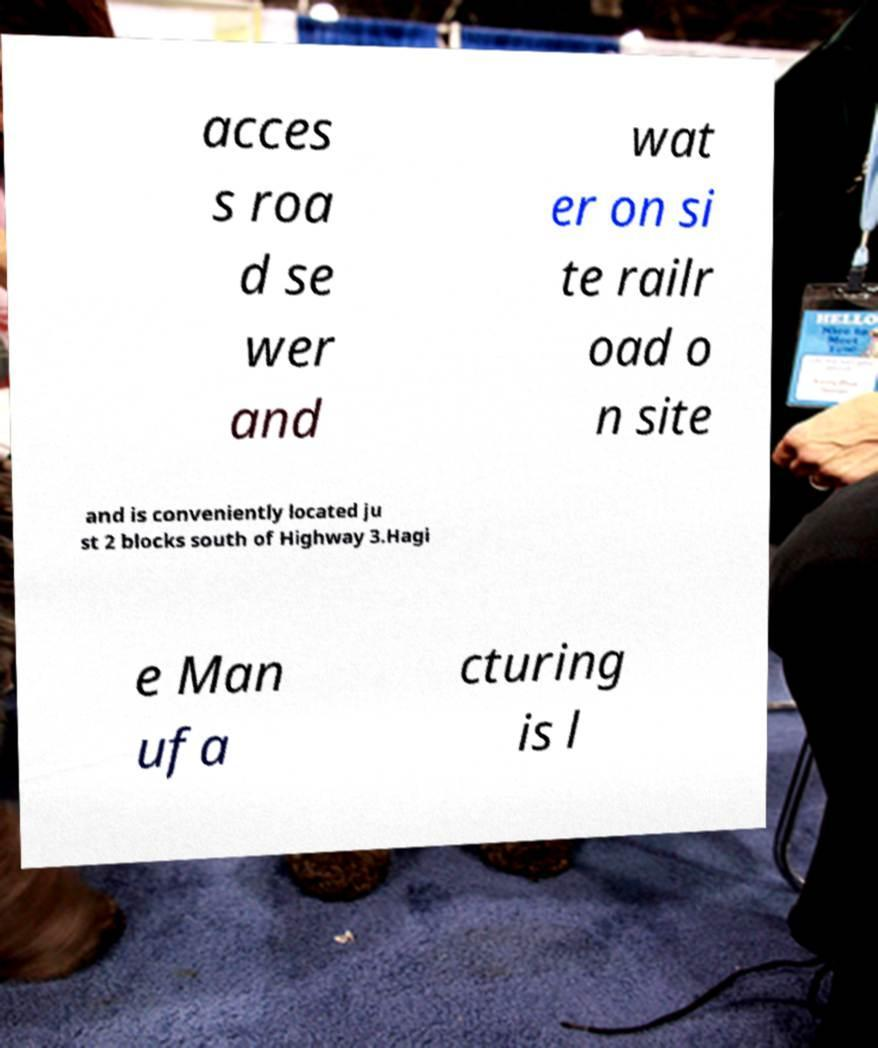For documentation purposes, I need the text within this image transcribed. Could you provide that? acces s roa d se wer and wat er on si te railr oad o n site and is conveniently located ju st 2 blocks south of Highway 3.Hagi e Man ufa cturing is l 